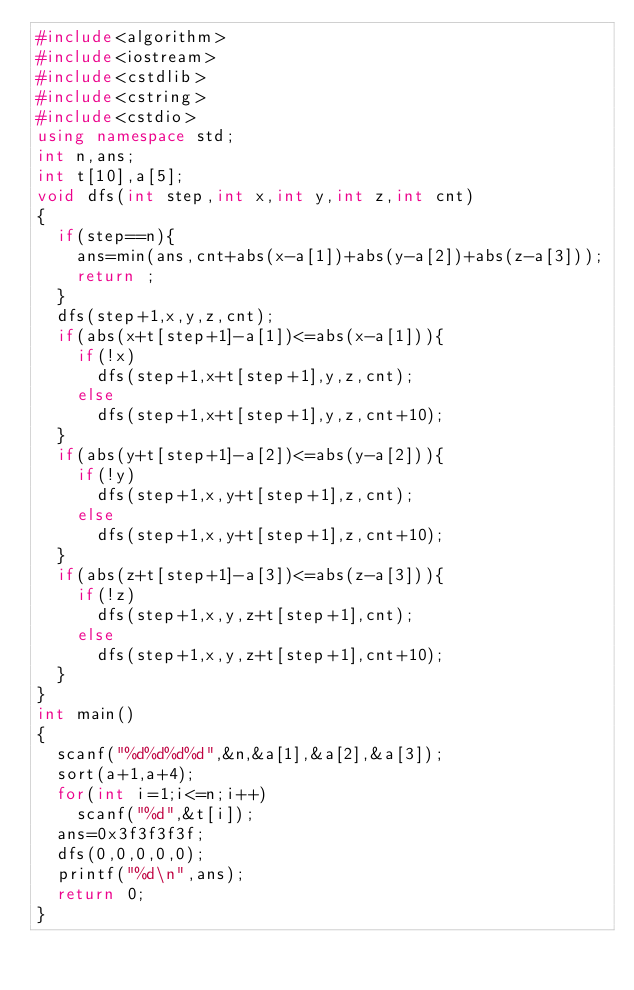<code> <loc_0><loc_0><loc_500><loc_500><_C++_>#include<algorithm>
#include<iostream>
#include<cstdlib>
#include<cstring>
#include<cstdio>
using namespace std;
int n,ans;
int t[10],a[5];
void dfs(int step,int x,int y,int z,int cnt)
{
	if(step==n){
		ans=min(ans,cnt+abs(x-a[1])+abs(y-a[2])+abs(z-a[3]));
		return ;
	}
	dfs(step+1,x,y,z,cnt);
	if(abs(x+t[step+1]-a[1])<=abs(x-a[1])){
		if(!x)
			dfs(step+1,x+t[step+1],y,z,cnt);
		else
			dfs(step+1,x+t[step+1],y,z,cnt+10);
	}
	if(abs(y+t[step+1]-a[2])<=abs(y-a[2])){
		if(!y)
			dfs(step+1,x,y+t[step+1],z,cnt);
		else
			dfs(step+1,x,y+t[step+1],z,cnt+10);
	}
	if(abs(z+t[step+1]-a[3])<=abs(z-a[3])){
		if(!z)
			dfs(step+1,x,y,z+t[step+1],cnt);
		else
			dfs(step+1,x,y,z+t[step+1],cnt+10);
	}
}
int main()
{
	scanf("%d%d%d%d",&n,&a[1],&a[2],&a[3]);
	sort(a+1,a+4);
	for(int i=1;i<=n;i++)
		scanf("%d",&t[i]);
	ans=0x3f3f3f3f;
	dfs(0,0,0,0,0);
	printf("%d\n",ans);
	return 0;
}</code> 